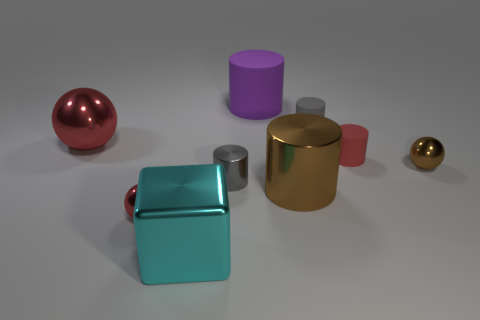Subtract all small metallic spheres. How many spheres are left? 1 Add 1 big cyan shiny objects. How many objects exist? 10 Subtract all brown spheres. How many spheres are left? 2 Subtract 1 blocks. How many blocks are left? 0 Subtract all cylinders. How many objects are left? 4 Subtract all blue cylinders. Subtract all blue cubes. How many cylinders are left? 5 Subtract all red cylinders. How many green balls are left? 0 Subtract all big red shiny spheres. Subtract all cubes. How many objects are left? 7 Add 1 big red shiny things. How many big red shiny things are left? 2 Add 1 brown cubes. How many brown cubes exist? 1 